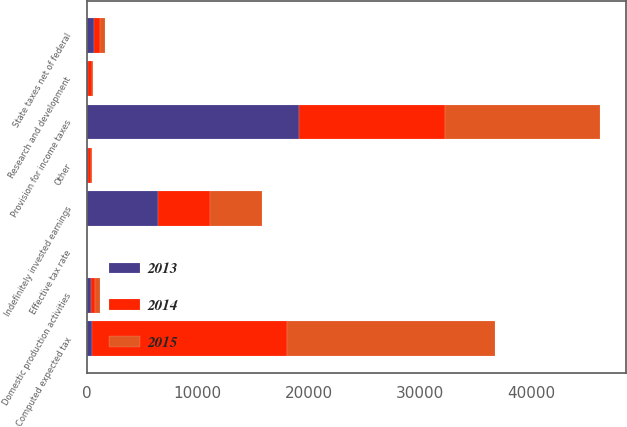Convert chart to OTSL. <chart><loc_0><loc_0><loc_500><loc_500><stacked_bar_chart><ecel><fcel>Computed expected tax<fcel>State taxes net of federal<fcel>Indefinitely invested earnings<fcel>Domestic production activities<fcel>Research and development<fcel>Other<fcel>Provision for income taxes<fcel>Effective tax rate<nl><fcel>2013<fcel>469<fcel>680<fcel>6470<fcel>426<fcel>171<fcel>128<fcel>19121<fcel>26.4<nl><fcel>2015<fcel>18719<fcel>469<fcel>4744<fcel>495<fcel>88<fcel>112<fcel>13973<fcel>26.1<nl><fcel>2014<fcel>17554<fcel>508<fcel>4614<fcel>308<fcel>287<fcel>265<fcel>13118<fcel>26.2<nl></chart> 